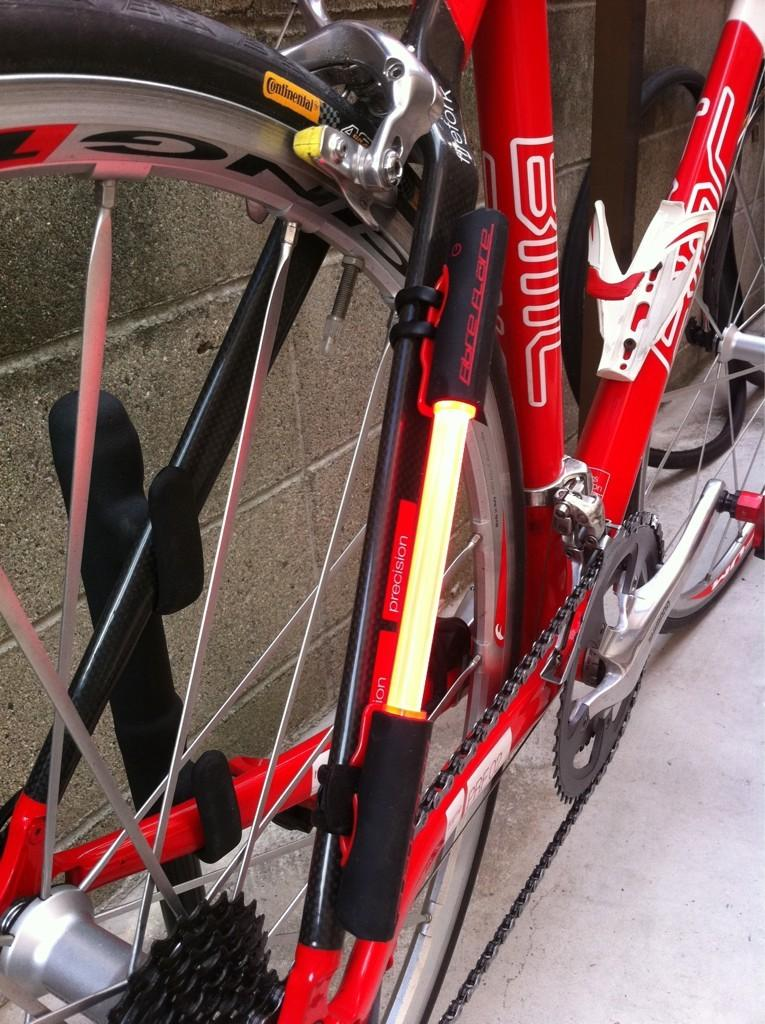What is the main object in the image? There is a red color cycle in the image. Where is the color cycle located? The cycle is parked on the floor. What can be seen in the background of the image? There is a wall in the background of the image. Which side of the image has a wheel? The wheel is on the left side of the image. What type of wheel is it? The wheel has tires. What might be used for sitting near the wheel? There are chairs associated with the wheel, which suggests they might be used for sitting. Where is the cat playing with a rake in the image? There is no cat or rake present in the image; it features a red color cycle parked on the floor. What type of toothpaste is used to clean the wheel in the image? There is no toothpaste mentioned or implied in the image; it only shows a red color cycle with a wheel and tires. 